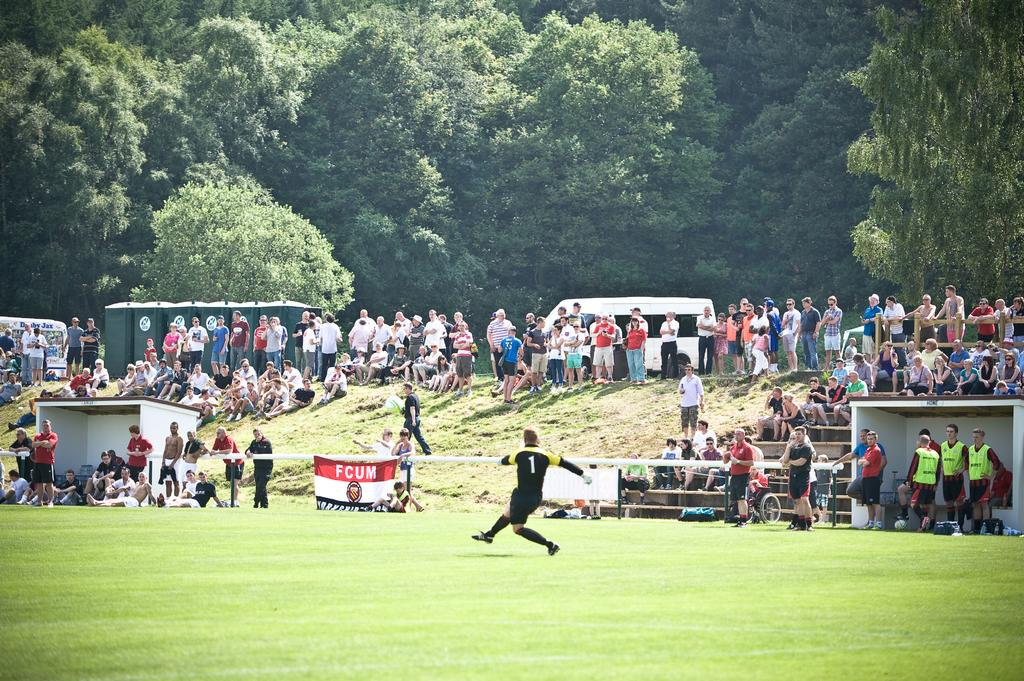What is the person in the image doing? There is a person running on the grass in the image. Are there any other people in the image? Yes, there are people standing and watching in the image. What else can be seen in the image besides people? There are vehicles and trees in the image. What type of stew is being served at the event in the image? There is no event or stew present in the image; it features a person running on the grass and other people watching. 